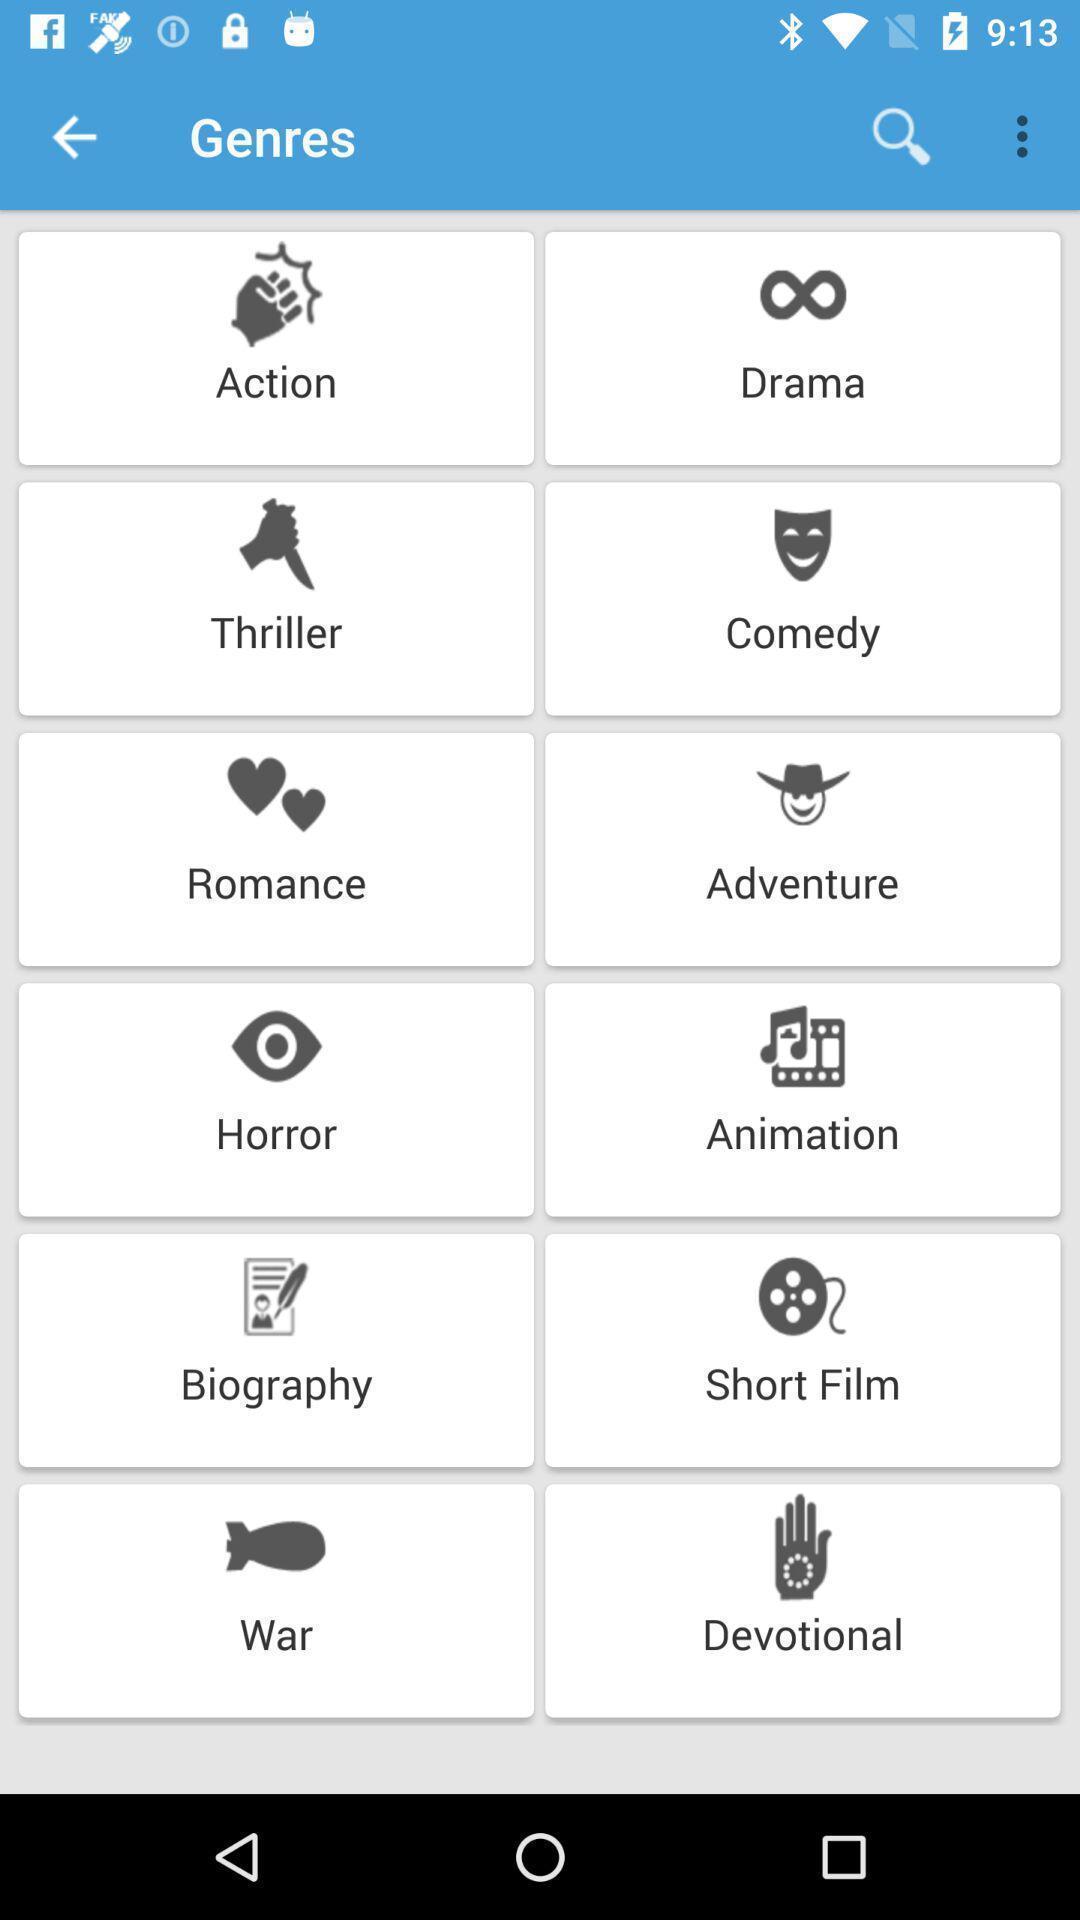Provide a detailed account of this screenshot. Page showing variety of genres. 